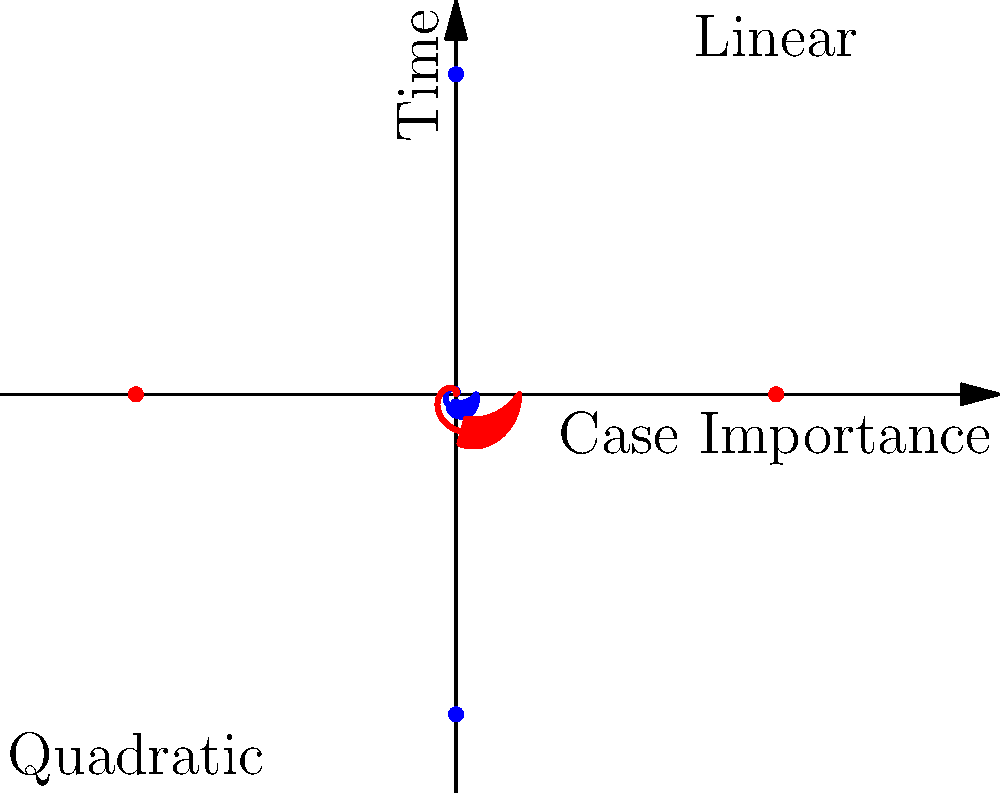In the spiral plot representing legal precedents, which type of spiral (blue or red) would be more suitable for illustrating a rapid increase in the interconnectedness of cases over time? To answer this question, let's analyze the two spiral plots:

1. Blue spiral: This is a linear spiral, where the radius increases linearly with the angle. It represents a constant rate of change.

2. Red spiral: This is a quadratic spiral, where the radius increases quadratically with the angle. It represents an accelerating rate of change.

3. In the context of legal precedents:
   - The angle represents time
   - The radius represents the importance or interconnectedness of cases

4. The rapid increase in interconnectedness over time suggests an accelerating pattern, where newer cases become increasingly connected to previous ones at a faster rate.

5. The red spiral (quadratic) shows this accelerating pattern:
   - It starts with a smaller radius (fewer connections)
   - As it progresses, the radius increases more rapidly (more connections being formed at an increasing rate)

6. The blue spiral (linear) shows a constant rate of change, which doesn't capture the "rapid increase" described in the question.

Therefore, the red spiral (quadratic) is more suitable for illustrating a rapid increase in the interconnectedness of cases over time.
Answer: Red (quadratic) spiral 